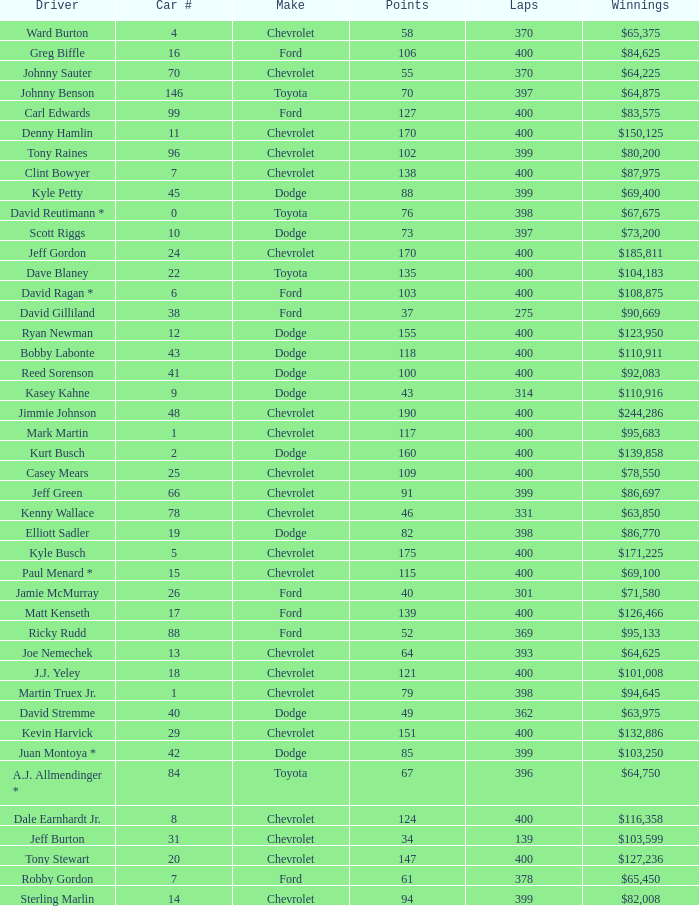What were the winnings for the Chevrolet with a number larger than 29 and scored 102 points? $80,200. 